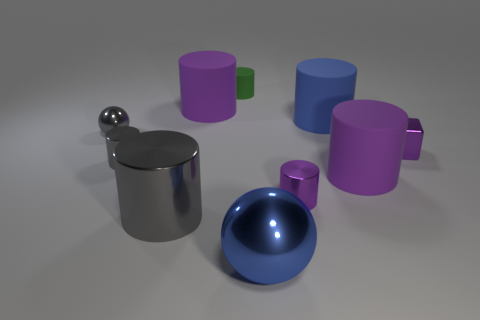What number of blocks are either purple things or large rubber objects? In the image, we see a collection of objects, some of which are purple. However, without specific information on the material properties of the objects, it's not possible to determine with certainty which are rubber. Based on color alone, there are three purple objects. Among the items present, none visibly appear to be blocks, but rather, there are cylindrical shapes and spherical shapes. So, if we're solely focusing on purple items, there are three. 